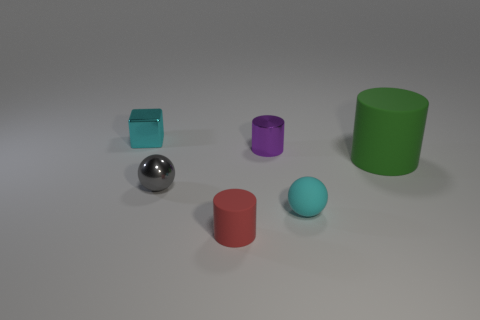Is the block made of the same material as the cyan thing that is in front of the small gray ball?
Offer a very short reply. No. How many red objects are either large cylinders or small rubber cylinders?
Make the answer very short. 1. Is there another cyan matte sphere that has the same size as the rubber sphere?
Offer a terse response. No. What material is the cyan object on the right side of the matte object left of the small cylinder that is behind the tiny red object?
Give a very brief answer. Rubber. Are there an equal number of small rubber cylinders that are to the right of the purple metallic thing and green cylinders?
Ensure brevity in your answer.  No. Does the small cylinder behind the gray thing have the same material as the ball to the right of the small rubber cylinder?
Provide a succinct answer. No. How many objects are green matte objects or cylinders that are in front of the large rubber cylinder?
Offer a terse response. 2. Is there a rubber object of the same shape as the cyan shiny object?
Offer a very short reply. No. How big is the ball on the left side of the small matte object that is in front of the cyan object that is on the right side of the small purple thing?
Make the answer very short. Small. Are there an equal number of tiny gray spheres that are to the left of the small rubber ball and tiny cylinders behind the small purple cylinder?
Provide a succinct answer. No. 